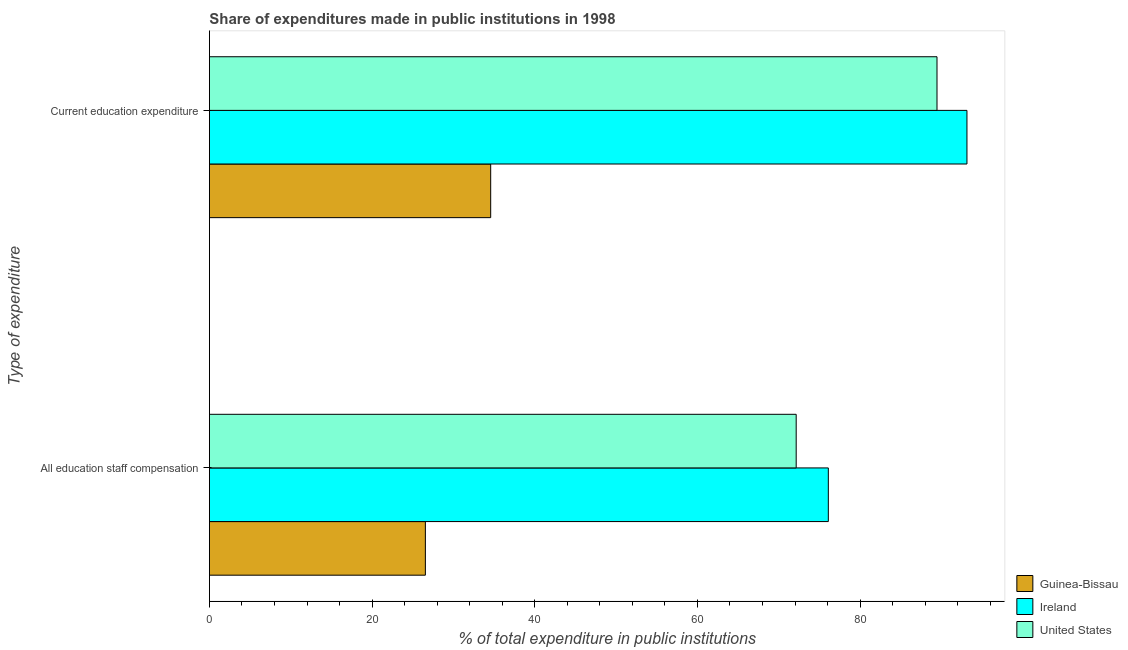How many different coloured bars are there?
Ensure brevity in your answer.  3. Are the number of bars per tick equal to the number of legend labels?
Provide a succinct answer. Yes. What is the label of the 1st group of bars from the top?
Offer a terse response. Current education expenditure. What is the expenditure in staff compensation in Ireland?
Offer a very short reply. 76.09. Across all countries, what is the maximum expenditure in education?
Provide a succinct answer. 93.14. Across all countries, what is the minimum expenditure in staff compensation?
Ensure brevity in your answer.  26.55. In which country was the expenditure in education maximum?
Ensure brevity in your answer.  Ireland. In which country was the expenditure in staff compensation minimum?
Keep it short and to the point. Guinea-Bissau. What is the total expenditure in staff compensation in the graph?
Provide a succinct answer. 174.79. What is the difference between the expenditure in education in Ireland and that in United States?
Provide a succinct answer. 3.68. What is the difference between the expenditure in education in United States and the expenditure in staff compensation in Ireland?
Ensure brevity in your answer.  13.36. What is the average expenditure in education per country?
Your response must be concise. 72.39. What is the difference between the expenditure in staff compensation and expenditure in education in United States?
Provide a succinct answer. -17.31. What is the ratio of the expenditure in education in United States to that in Ireland?
Your answer should be very brief. 0.96. In how many countries, is the expenditure in staff compensation greater than the average expenditure in staff compensation taken over all countries?
Provide a short and direct response. 2. What does the 3rd bar from the top in All education staff compensation represents?
Give a very brief answer. Guinea-Bissau. What does the 1st bar from the bottom in Current education expenditure represents?
Provide a short and direct response. Guinea-Bissau. How many countries are there in the graph?
Offer a very short reply. 3. What is the difference between two consecutive major ticks on the X-axis?
Offer a very short reply. 20. Are the values on the major ticks of X-axis written in scientific E-notation?
Give a very brief answer. No. Does the graph contain any zero values?
Make the answer very short. No. Does the graph contain grids?
Give a very brief answer. No. How many legend labels are there?
Give a very brief answer. 3. What is the title of the graph?
Ensure brevity in your answer.  Share of expenditures made in public institutions in 1998. Does "Argentina" appear as one of the legend labels in the graph?
Make the answer very short. No. What is the label or title of the X-axis?
Your answer should be compact. % of total expenditure in public institutions. What is the label or title of the Y-axis?
Provide a succinct answer. Type of expenditure. What is the % of total expenditure in public institutions in Guinea-Bissau in All education staff compensation?
Your answer should be very brief. 26.55. What is the % of total expenditure in public institutions in Ireland in All education staff compensation?
Your answer should be compact. 76.09. What is the % of total expenditure in public institutions in United States in All education staff compensation?
Ensure brevity in your answer.  72.14. What is the % of total expenditure in public institutions of Guinea-Bissau in Current education expenditure?
Provide a short and direct response. 34.58. What is the % of total expenditure in public institutions of Ireland in Current education expenditure?
Make the answer very short. 93.14. What is the % of total expenditure in public institutions in United States in Current education expenditure?
Ensure brevity in your answer.  89.46. Across all Type of expenditure, what is the maximum % of total expenditure in public institutions of Guinea-Bissau?
Make the answer very short. 34.58. Across all Type of expenditure, what is the maximum % of total expenditure in public institutions of Ireland?
Your answer should be compact. 93.14. Across all Type of expenditure, what is the maximum % of total expenditure in public institutions of United States?
Provide a succinct answer. 89.46. Across all Type of expenditure, what is the minimum % of total expenditure in public institutions in Guinea-Bissau?
Your answer should be very brief. 26.55. Across all Type of expenditure, what is the minimum % of total expenditure in public institutions in Ireland?
Provide a succinct answer. 76.09. Across all Type of expenditure, what is the minimum % of total expenditure in public institutions of United States?
Keep it short and to the point. 72.14. What is the total % of total expenditure in public institutions in Guinea-Bissau in the graph?
Offer a very short reply. 61.13. What is the total % of total expenditure in public institutions of Ireland in the graph?
Your answer should be compact. 169.23. What is the total % of total expenditure in public institutions of United States in the graph?
Keep it short and to the point. 161.6. What is the difference between the % of total expenditure in public institutions in Guinea-Bissau in All education staff compensation and that in Current education expenditure?
Ensure brevity in your answer.  -8.03. What is the difference between the % of total expenditure in public institutions in Ireland in All education staff compensation and that in Current education expenditure?
Offer a very short reply. -17.04. What is the difference between the % of total expenditure in public institutions in United States in All education staff compensation and that in Current education expenditure?
Provide a short and direct response. -17.31. What is the difference between the % of total expenditure in public institutions of Guinea-Bissau in All education staff compensation and the % of total expenditure in public institutions of Ireland in Current education expenditure?
Provide a succinct answer. -66.59. What is the difference between the % of total expenditure in public institutions in Guinea-Bissau in All education staff compensation and the % of total expenditure in public institutions in United States in Current education expenditure?
Give a very brief answer. -62.9. What is the difference between the % of total expenditure in public institutions of Ireland in All education staff compensation and the % of total expenditure in public institutions of United States in Current education expenditure?
Your answer should be very brief. -13.36. What is the average % of total expenditure in public institutions in Guinea-Bissau per Type of expenditure?
Keep it short and to the point. 30.57. What is the average % of total expenditure in public institutions in Ireland per Type of expenditure?
Make the answer very short. 84.62. What is the average % of total expenditure in public institutions of United States per Type of expenditure?
Give a very brief answer. 80.8. What is the difference between the % of total expenditure in public institutions in Guinea-Bissau and % of total expenditure in public institutions in Ireland in All education staff compensation?
Ensure brevity in your answer.  -49.54. What is the difference between the % of total expenditure in public institutions in Guinea-Bissau and % of total expenditure in public institutions in United States in All education staff compensation?
Offer a terse response. -45.59. What is the difference between the % of total expenditure in public institutions of Ireland and % of total expenditure in public institutions of United States in All education staff compensation?
Your answer should be very brief. 3.95. What is the difference between the % of total expenditure in public institutions in Guinea-Bissau and % of total expenditure in public institutions in Ireland in Current education expenditure?
Ensure brevity in your answer.  -58.56. What is the difference between the % of total expenditure in public institutions of Guinea-Bissau and % of total expenditure in public institutions of United States in Current education expenditure?
Your answer should be compact. -54.87. What is the difference between the % of total expenditure in public institutions of Ireland and % of total expenditure in public institutions of United States in Current education expenditure?
Ensure brevity in your answer.  3.68. What is the ratio of the % of total expenditure in public institutions in Guinea-Bissau in All education staff compensation to that in Current education expenditure?
Your response must be concise. 0.77. What is the ratio of the % of total expenditure in public institutions in Ireland in All education staff compensation to that in Current education expenditure?
Ensure brevity in your answer.  0.82. What is the ratio of the % of total expenditure in public institutions in United States in All education staff compensation to that in Current education expenditure?
Ensure brevity in your answer.  0.81. What is the difference between the highest and the second highest % of total expenditure in public institutions in Guinea-Bissau?
Your answer should be compact. 8.03. What is the difference between the highest and the second highest % of total expenditure in public institutions of Ireland?
Offer a very short reply. 17.04. What is the difference between the highest and the second highest % of total expenditure in public institutions of United States?
Your answer should be compact. 17.31. What is the difference between the highest and the lowest % of total expenditure in public institutions in Guinea-Bissau?
Provide a succinct answer. 8.03. What is the difference between the highest and the lowest % of total expenditure in public institutions in Ireland?
Keep it short and to the point. 17.04. What is the difference between the highest and the lowest % of total expenditure in public institutions of United States?
Ensure brevity in your answer.  17.31. 